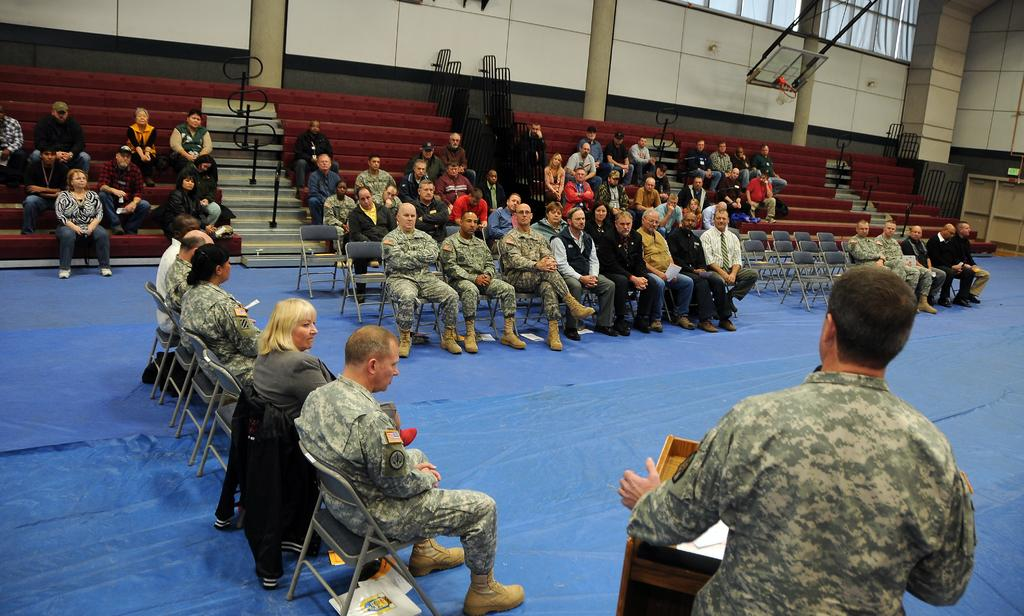Where are the people sitting in the image? There are people sitting in the bottom right hand corner of the image and on the left side of the image. How many groups of people can be seen sitting in the image? There are two groups of people sitting in the image, one in the bottom right hand corner and the other on the left side. What type of view can be seen from the side of the people sitting on the left side of the image? There is no specific view mentioned in the image, and the image does not provide information about the view from the side of the people sitting on the left side. 